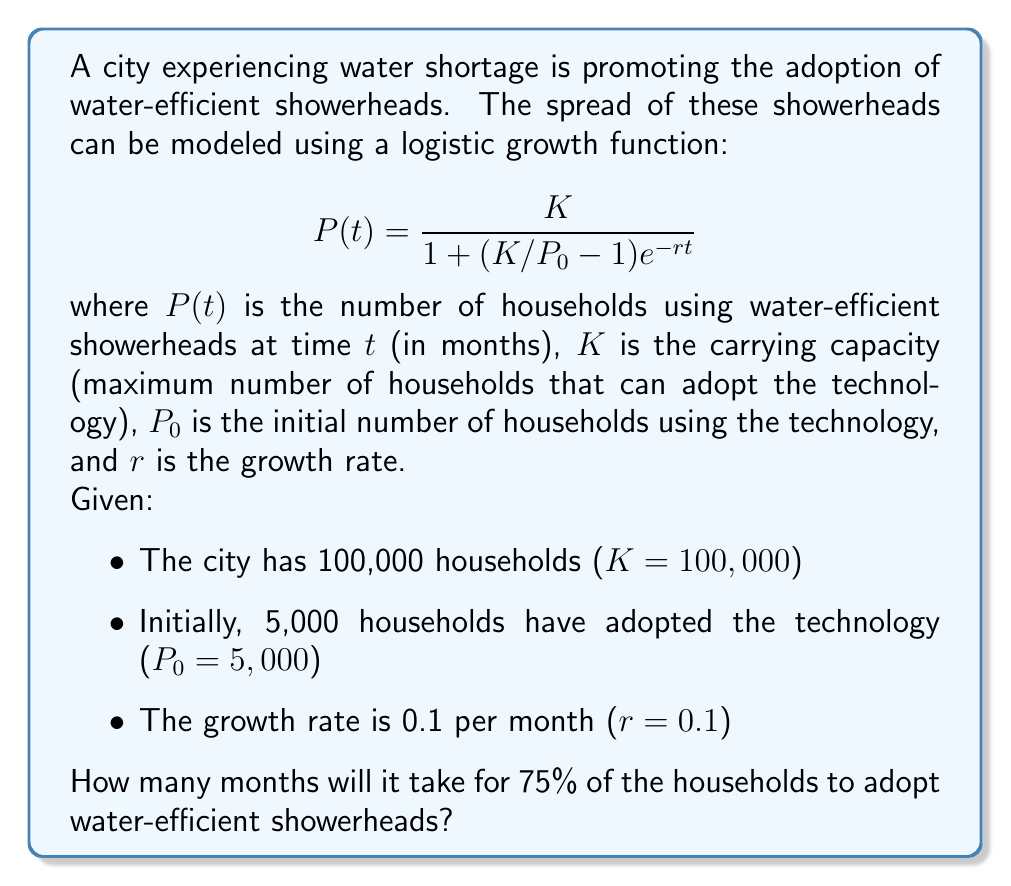Provide a solution to this math problem. To solve this problem, we need to follow these steps:

1) We want to find $t$ when $P(t) = 0.75K = 75,000$ households.

2) Substitute the known values into the logistic growth equation:

   $$75000 = \frac{100000}{1 + (100000/5000 - 1)e^{-0.1t}}$$

3) Simplify:
   
   $$75000 = \frac{100000}{1 + 19e^{-0.1t}}$$

4) Multiply both sides by $(1 + 19e^{-0.1t})$:
   
   $$75000(1 + 19e^{-0.1t}) = 100000$$

5) Expand:
   
   $$75000 + 1425000e^{-0.1t} = 100000$$

6) Subtract 75000 from both sides:
   
   $$1425000e^{-0.1t} = 25000$$

7) Divide both sides by 1425000:
   
   $$e^{-0.1t} = \frac{25000}{1425000} = \frac{1}{57}$$

8) Take the natural logarithm of both sides:
   
   $$-0.1t = \ln(\frac{1}{57})$$

9) Divide both sides by -0.1:
   
   $$t = -\frac{\ln(\frac{1}{57})}{0.1} = \frac{\ln(57)}{0.1}$$

10) Calculate the final result:
    
    $$t \approx 40.47$$ months
Answer: $\frac{\ln(57)}{0.1} \approx 40.47$ months 